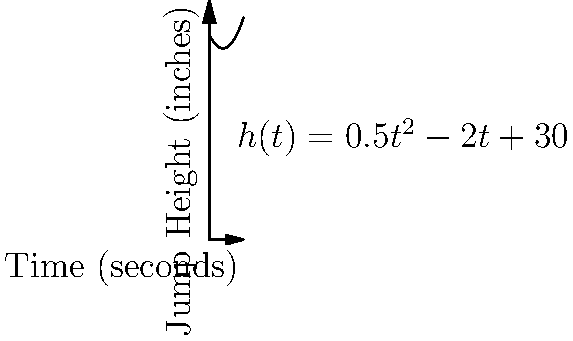A star player from the Americus-Sumter basketball team is practicing vertical jumps. The height $h$ (in inches) of the player's jump as a function of time $t$ (in seconds) is given by the equation $h(t) = 0.5t^2 - 2t + 30$. At what time does the player reach the maximum height of their jump? To find the time when the player reaches the maximum height, we need to follow these steps:

1) The maximum height occurs when the rate of change (velocity) is zero. This means we need to find when $\frac{dh}{dt} = 0$.

2) Let's find $\frac{dh}{dt}$ by differentiating $h(t)$:
   $$\frac{dh}{dt} = \frac{d}{dt}(0.5t^2 - 2t + 30) = t - 2$$

3) Now, we set this equal to zero and solve for $t$:
   $$t - 2 = 0$$
   $$t = 2$$

4) To confirm this is a maximum (not a minimum), we can check the second derivative:
   $$\frac{d^2h}{dt^2} = \frac{d}{dt}(t - 2) = 1$$
   Since this is positive, we confirm that $t = 2$ gives a maximum.

Therefore, the player reaches the maximum height of their jump at $t = 2$ seconds.
Answer: 2 seconds 